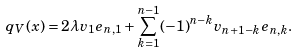<formula> <loc_0><loc_0><loc_500><loc_500>q _ { V } ( x ) = 2 \lambda v _ { 1 } e _ { n , 1 } + \sum _ { k = 1 } ^ { n - 1 } ( - 1 ) ^ { n - k } v _ { n + 1 - k } e _ { n , k } .</formula> 